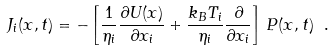<formula> <loc_0><loc_0><loc_500><loc_500>J _ { i } ( { x } , t ) = - \left [ \frac { 1 } { \eta _ { i } } \frac { \partial U ( { x } ) } { \partial x _ { i } } + \frac { k _ { B } T _ { i } } { \eta _ { i } } \frac { \partial } { \partial x _ { i } } \right ] \, P ( { x } , t ) \ .</formula> 